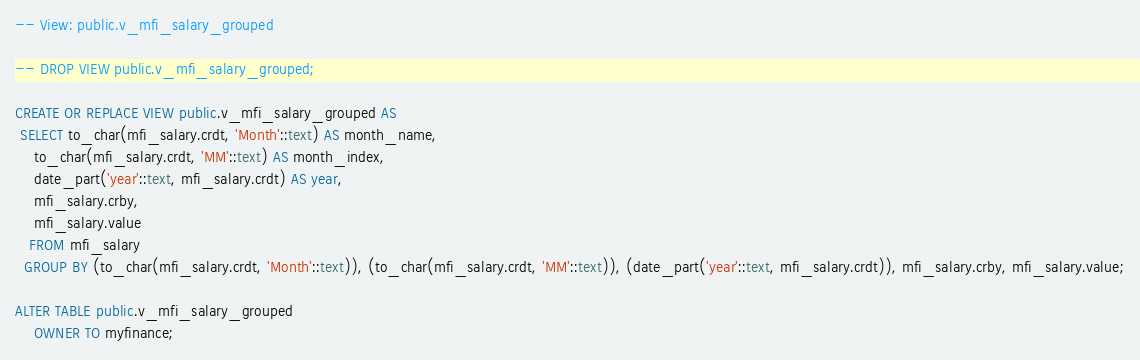<code> <loc_0><loc_0><loc_500><loc_500><_SQL_>-- View: public.v_mfi_salary_grouped

-- DROP VIEW public.v_mfi_salary_grouped;

CREATE OR REPLACE VIEW public.v_mfi_salary_grouped AS
 SELECT to_char(mfi_salary.crdt, 'Month'::text) AS month_name,
    to_char(mfi_salary.crdt, 'MM'::text) AS month_index,
    date_part('year'::text, mfi_salary.crdt) AS year,
    mfi_salary.crby,
    mfi_salary.value
   FROM mfi_salary
  GROUP BY (to_char(mfi_salary.crdt, 'Month'::text)), (to_char(mfi_salary.crdt, 'MM'::text)), (date_part('year'::text, mfi_salary.crdt)), mfi_salary.crby, mfi_salary.value;

ALTER TABLE public.v_mfi_salary_grouped
    OWNER TO myfinance;


</code> 